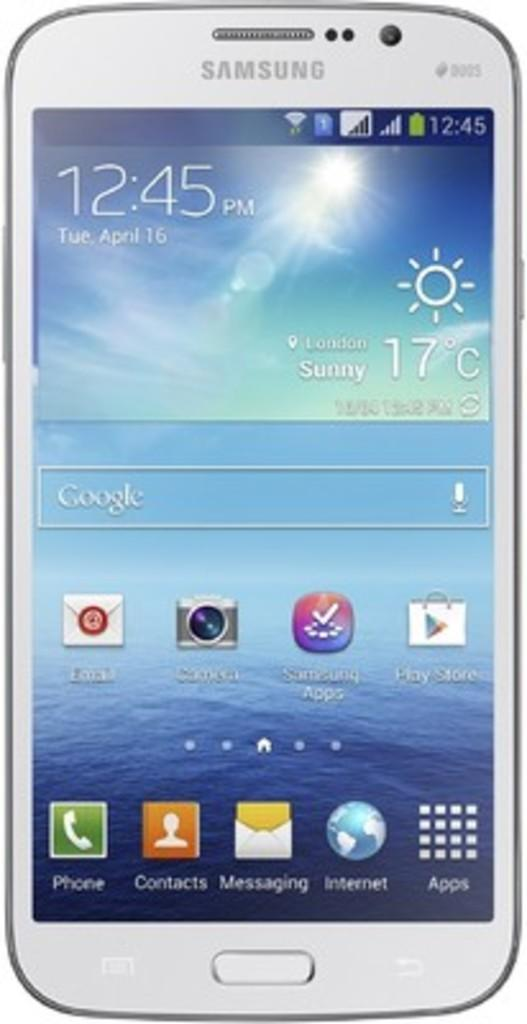<image>
Offer a succinct explanation of the picture presented. The home screen of a white Samsung phone. 